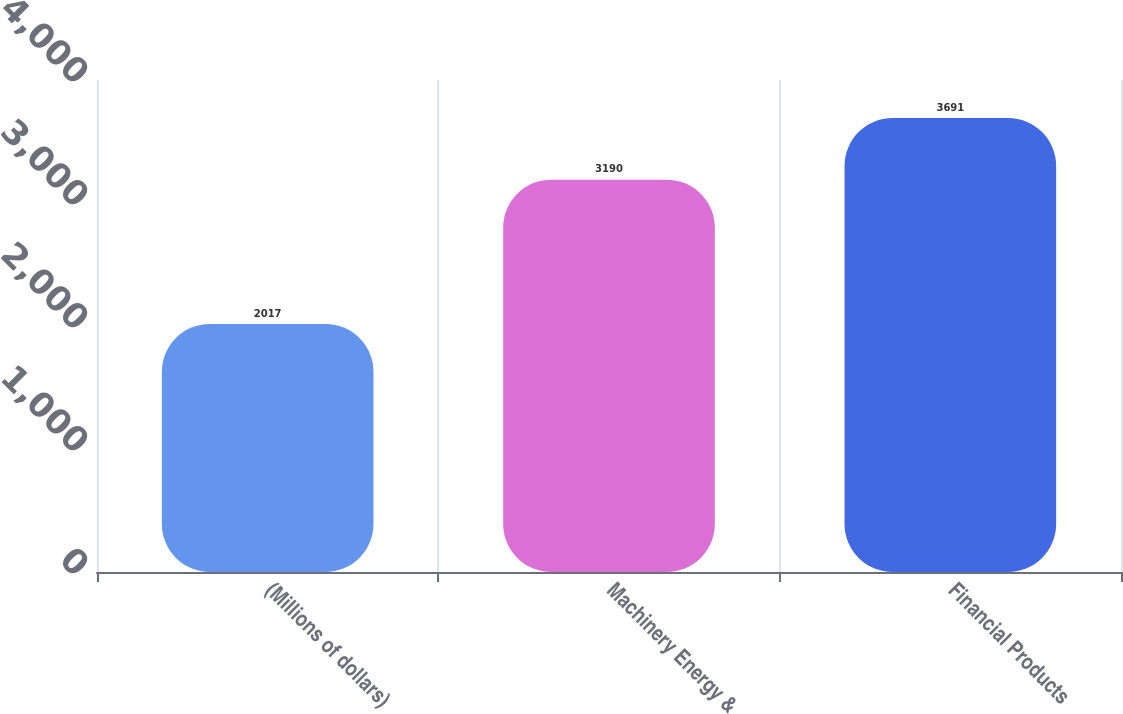<chart> <loc_0><loc_0><loc_500><loc_500><bar_chart><fcel>(Millions of dollars)<fcel>Machinery Energy &<fcel>Financial Products<nl><fcel>2017<fcel>3190<fcel>3691<nl></chart> 